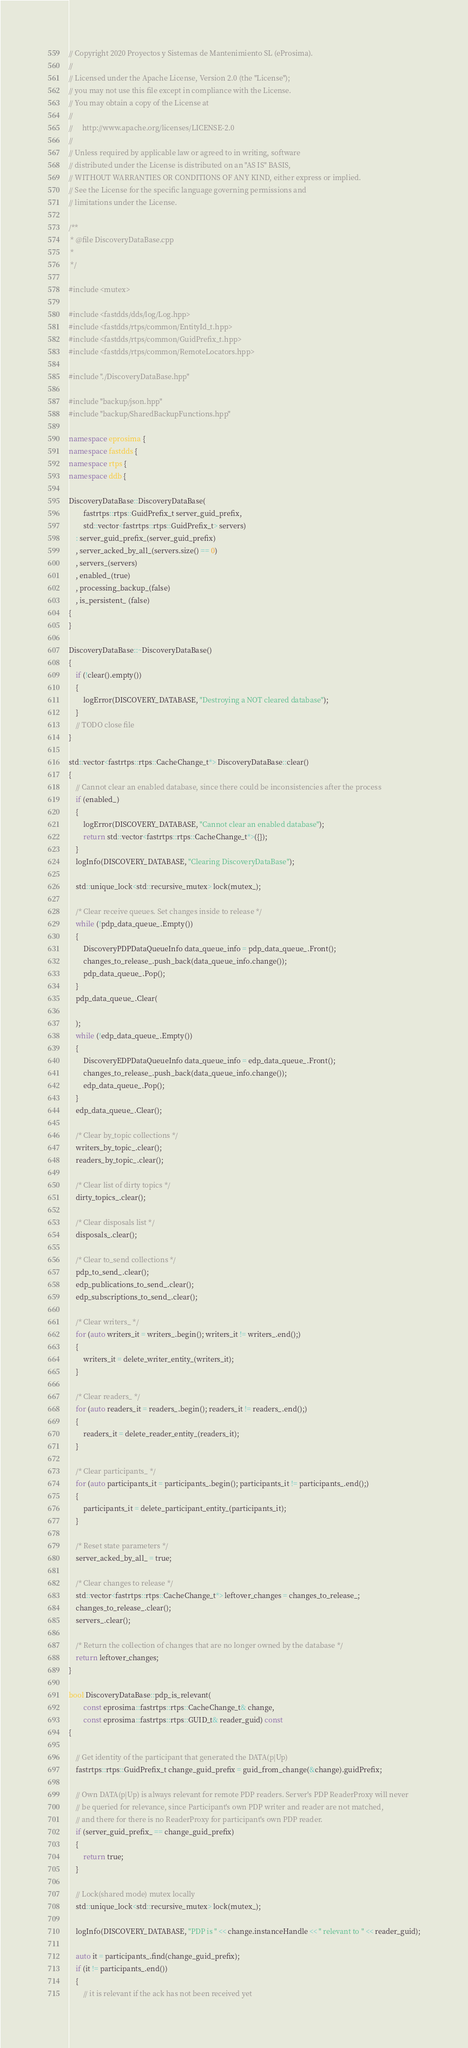<code> <loc_0><loc_0><loc_500><loc_500><_C++_>// Copyright 2020 Proyectos y Sistemas de Mantenimiento SL (eProsima).
//
// Licensed under the Apache License, Version 2.0 (the "License");
// you may not use this file except in compliance with the License.
// You may obtain a copy of the License at
//
//     http://www.apache.org/licenses/LICENSE-2.0
//
// Unless required by applicable law or agreed to in writing, software
// distributed under the License is distributed on an "AS IS" BASIS,
// WITHOUT WARRANTIES OR CONDITIONS OF ANY KIND, either express or implied.
// See the License for the specific language governing permissions and
// limitations under the License.

/**
 * @file DiscoveryDataBase.cpp
 *
 */

#include <mutex>

#include <fastdds/dds/log/Log.hpp>
#include <fastdds/rtps/common/EntityId_t.hpp>
#include <fastdds/rtps/common/GuidPrefix_t.hpp>
#include <fastdds/rtps/common/RemoteLocators.hpp>

#include "./DiscoveryDataBase.hpp"

#include "backup/json.hpp"
#include "backup/SharedBackupFunctions.hpp"

namespace eprosima {
namespace fastdds {
namespace rtps {
namespace ddb {

DiscoveryDataBase::DiscoveryDataBase(
        fastrtps::rtps::GuidPrefix_t server_guid_prefix,
        std::vector<fastrtps::rtps::GuidPrefix_t> servers)
    : server_guid_prefix_(server_guid_prefix)
    , server_acked_by_all_(servers.size() == 0)
    , servers_(servers)
    , enabled_(true)
    , processing_backup_(false)
    , is_persistent_ (false)
{
}

DiscoveryDataBase::~DiscoveryDataBase()
{
    if (!clear().empty())
    {
        logError(DISCOVERY_DATABASE, "Destroying a NOT cleared database");
    }
    // TODO close file
}

std::vector<fastrtps::rtps::CacheChange_t*> DiscoveryDataBase::clear()
{
    // Cannot clear an enabled database, since there could be inconsistencies after the process
    if (enabled_)
    {
        logError(DISCOVERY_DATABASE, "Cannot clear an enabled database");
        return std::vector<fastrtps::rtps::CacheChange_t*>({});
    }
    logInfo(DISCOVERY_DATABASE, "Clearing DiscoveryDataBase");

    std::unique_lock<std::recursive_mutex> lock(mutex_);

    /* Clear receive queues. Set changes inside to release */
    while (!pdp_data_queue_.Empty())
    {
        DiscoveryPDPDataQueueInfo data_queue_info = pdp_data_queue_.Front();
        changes_to_release_.push_back(data_queue_info.change());
        pdp_data_queue_.Pop();
    }
    pdp_data_queue_.Clear(

    );
    while (!edp_data_queue_.Empty())
    {
        DiscoveryEDPDataQueueInfo data_queue_info = edp_data_queue_.Front();
        changes_to_release_.push_back(data_queue_info.change());
        edp_data_queue_.Pop();
    }
    edp_data_queue_.Clear();

    /* Clear by_topic collections */
    writers_by_topic_.clear();
    readers_by_topic_.clear();

    /* Clear list of dirty topics */
    dirty_topics_.clear();

    /* Clear disposals list */
    disposals_.clear();

    /* Clear to_send collections */
    pdp_to_send_.clear();
    edp_publications_to_send_.clear();
    edp_subscriptions_to_send_.clear();

    /* Clear writers_ */
    for (auto writers_it = writers_.begin(); writers_it != writers_.end();)
    {
        writers_it = delete_writer_entity_(writers_it);
    }

    /* Clear readers_ */
    for (auto readers_it = readers_.begin(); readers_it != readers_.end();)
    {
        readers_it = delete_reader_entity_(readers_it);
    }

    /* Clear participants_ */
    for (auto participants_it = participants_.begin(); participants_it != participants_.end();)
    {
        participants_it = delete_participant_entity_(participants_it);
    }

    /* Reset state parameters */
    server_acked_by_all_ = true;

    /* Clear changes to release */
    std::vector<fastrtps::rtps::CacheChange_t*> leftover_changes = changes_to_release_;
    changes_to_release_.clear();
    servers_.clear();

    /* Return the collection of changes that are no longer owned by the database */
    return leftover_changes;
}

bool DiscoveryDataBase::pdp_is_relevant(
        const eprosima::fastrtps::rtps::CacheChange_t& change,
        const eprosima::fastrtps::rtps::GUID_t& reader_guid) const
{

    // Get identity of the participant that generated the DATA(p|Up)
    fastrtps::rtps::GuidPrefix_t change_guid_prefix = guid_from_change(&change).guidPrefix;

    // Own DATA(p|Up) is always relevant for remote PDP readers. Server's PDP ReaderProxy will never
    // be queried for relevance, since Participant's own PDP writer and reader are not matched,
    // and there for there is no ReaderProxy for participant's own PDP reader.
    if (server_guid_prefix_ == change_guid_prefix)
    {
        return true;
    }

    // Lock(shared mode) mutex locally
    std::unique_lock<std::recursive_mutex> lock(mutex_);

    logInfo(DISCOVERY_DATABASE, "PDP is " << change.instanceHandle << " relevant to " << reader_guid);

    auto it = participants_.find(change_guid_prefix);
    if (it != participants_.end())
    {
        // it is relevant if the ack has not been received yet</code> 